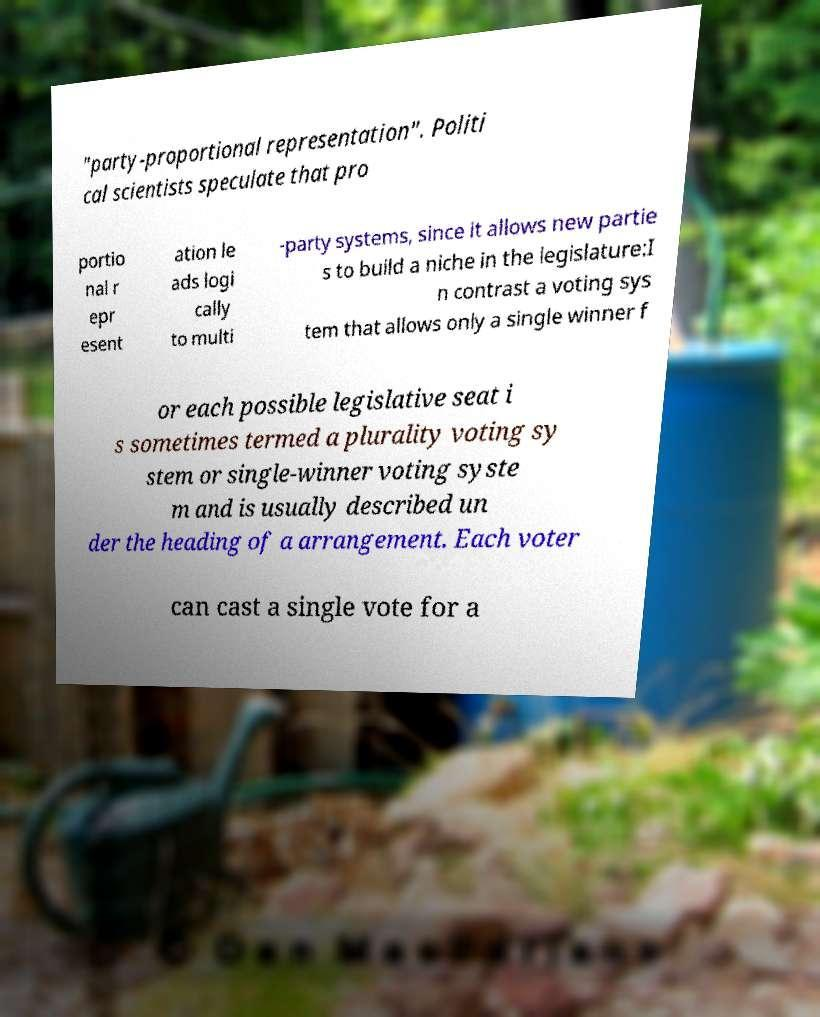Can you read and provide the text displayed in the image?This photo seems to have some interesting text. Can you extract and type it out for me? "party-proportional representation". Politi cal scientists speculate that pro portio nal r epr esent ation le ads logi cally to multi -party systems, since it allows new partie s to build a niche in the legislature:I n contrast a voting sys tem that allows only a single winner f or each possible legislative seat i s sometimes termed a plurality voting sy stem or single-winner voting syste m and is usually described un der the heading of a arrangement. Each voter can cast a single vote for a 